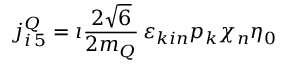<formula> <loc_0><loc_0><loc_500><loc_500>j _ { i \, 5 } ^ { Q } = \imath \frac { 2 \sqrt { 6 } } { 2 m _ { Q } } \, \varepsilon _ { k i n } p _ { k } \chi _ { n } \eta _ { 0 }</formula> 